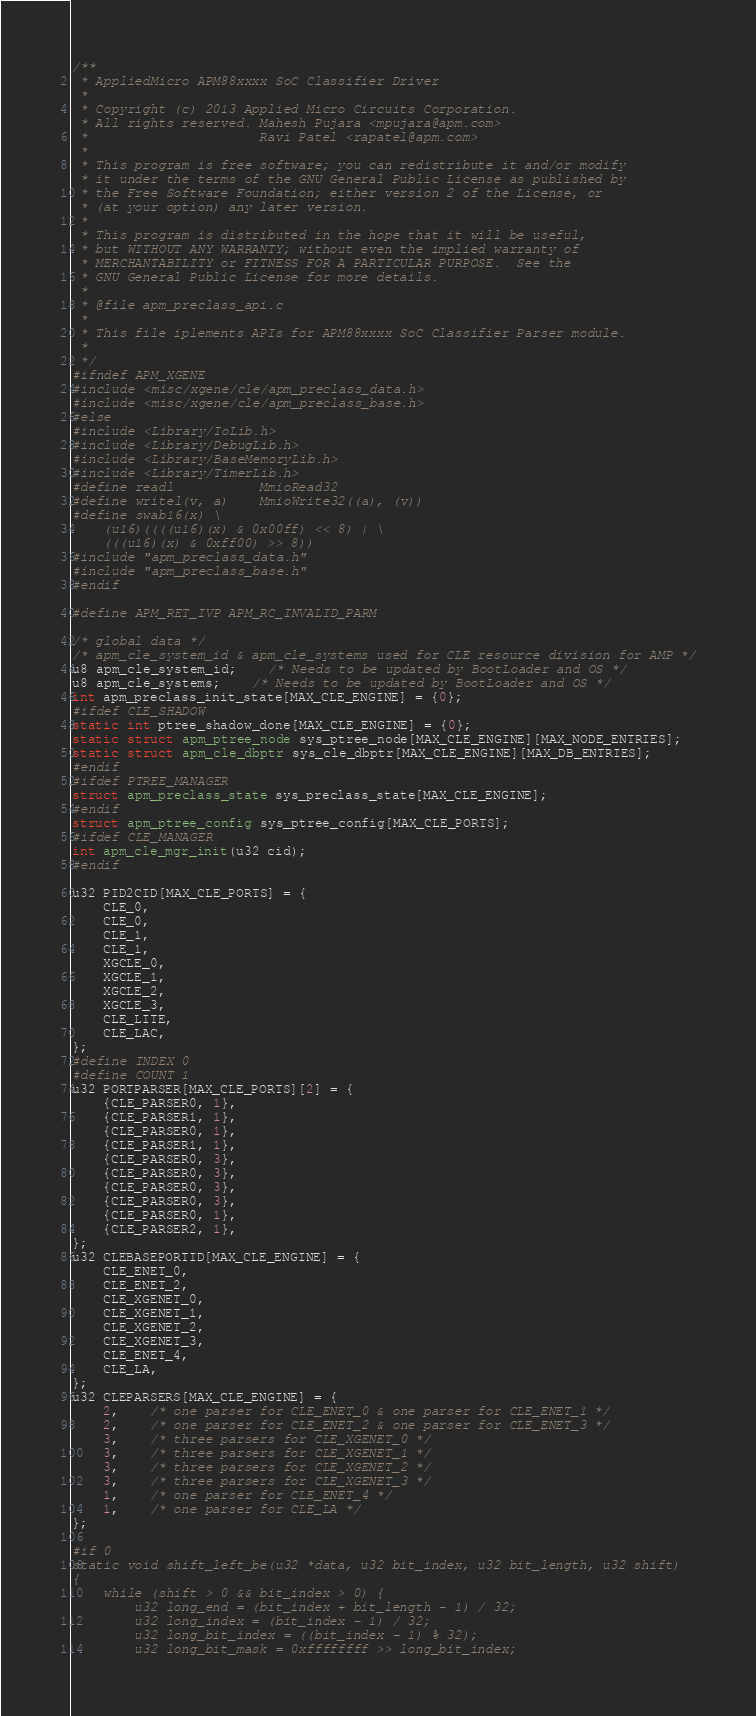<code> <loc_0><loc_0><loc_500><loc_500><_C_>/**
 * AppliedMicro APM88xxxx SoC Classifier Driver
 *
 * Copyright (c) 2013 Applied Micro Circuits Corporation.
 * All rights reserved. Mahesh Pujara <mpujara@apm.com>
 *                      Ravi Patel <rapatel@apm.com>
 *
 * This program is free software; you can redistribute it and/or modify
 * it under the terms of the GNU General Public License as published by
 * the Free Software Foundation; either version 2 of the License, or
 * (at your option) any later version.
 *
 * This program is distributed in the hope that it will be useful,
 * but WITHOUT ANY WARRANTY; without even the implied warranty of
 * MERCHANTABILITY or FITNESS FOR A PARTICULAR PURPOSE.	 See the
 * GNU General Public License for more details.
 *
 * @file apm_preclass_api.c
 *
 * This file iplements APIs for APM88xxxx SoC Classifier Parser module.
 *
 */
#ifndef APM_XGENE
#include <misc/xgene/cle/apm_preclass_data.h>
#include <misc/xgene/cle/apm_preclass_base.h>
#else
#include <Library/IoLib.h>
#include <Library/DebugLib.h>
#include <Library/BaseMemoryLib.h>
#include <Library/TimerLib.h>
#define readl           MmioRead32
#define writel(v, a)    MmioWrite32((a), (v))
#define swab16(x) \
	(u16)((((u16)(x) & 0x00ff) << 8) | \
	(((u16)(x) & 0xff00) >> 8))
#include "apm_preclass_data.h"
#include "apm_preclass_base.h"
#endif

#define APM_RET_IVP APM_RC_INVALID_PARM

/* global data */
/* apm_cle_system_id & apm_cle_systems used for CLE resource division for AMP */
u8 apm_cle_system_id;	/* Needs to be updated by BootLoader and OS */
u8 apm_cle_systems;	/* Needs to be updated by BootLoader and OS */
int apm_preclass_init_state[MAX_CLE_ENGINE] = {0};
#ifdef CLE_SHADOW
static int ptree_shadow_done[MAX_CLE_ENGINE] = {0};
static struct apm_ptree_node sys_ptree_node[MAX_CLE_ENGINE][MAX_NODE_ENTRIES];
static struct apm_cle_dbptr sys_cle_dbptr[MAX_CLE_ENGINE][MAX_DB_ENTRIES];
#endif
#ifdef PTREE_MANAGER
struct apm_preclass_state sys_preclass_state[MAX_CLE_ENGINE];
#endif
struct apm_ptree_config sys_ptree_config[MAX_CLE_PORTS];
#ifdef CLE_MANAGER
int apm_cle_mgr_init(u32 cid);
#endif

u32 PID2CID[MAX_CLE_PORTS] = {
	CLE_0,
	CLE_0,
	CLE_1,
	CLE_1,
	XGCLE_0,
	XGCLE_1,
	XGCLE_2,
	XGCLE_3,
	CLE_LITE,
	CLE_LAC,
};
#define INDEX 0
#define COUNT 1
u32 PORTPARSER[MAX_CLE_PORTS][2] = {
	{CLE_PARSER0, 1},
	{CLE_PARSER1, 1},
	{CLE_PARSER0, 1},
	{CLE_PARSER1, 1},
	{CLE_PARSER0, 3},
	{CLE_PARSER0, 3},
	{CLE_PARSER0, 3},
	{CLE_PARSER0, 3},
	{CLE_PARSER0, 1},
	{CLE_PARSER2, 1},
};
u32 CLEBASEPORTID[MAX_CLE_ENGINE] = {
	CLE_ENET_0,
	CLE_ENET_2,
	CLE_XGENET_0,
	CLE_XGENET_1,
	CLE_XGENET_2,
	CLE_XGENET_3,
	CLE_ENET_4,
	CLE_LA,
};
u32 CLEPARSERS[MAX_CLE_ENGINE] = {
	2,	/* one parser for CLE_ENET_0 & one parser for CLE_ENET_1 */
	2,	/* one parser for CLE_ENET_2 & one parser for CLE_ENET_3 */
	3,	/* three parsers for CLE_XGENET_0 */
	3,	/* three parsers for CLE_XGENET_1 */
	3,	/* three parsers for CLE_XGENET_2 */
	3,	/* three parsers for CLE_XGENET_3 */
	1,	/* one parser for CLE_ENET_4 */
	1,	/* one parser for CLE_LA */
};

#if 0
static void shift_left_be(u32 *data, u32 bit_index, u32 bit_length, u32 shift)
{
	while (shift > 0 && bit_index > 0) {
		u32 long_end = (bit_index + bit_length - 1) / 32;
		u32 long_index = (bit_index - 1) / 32;
		u32 long_bit_index = ((bit_index - 1) % 32);
		u32 long_bit_mask = 0xffffffff >> long_bit_index;</code> 